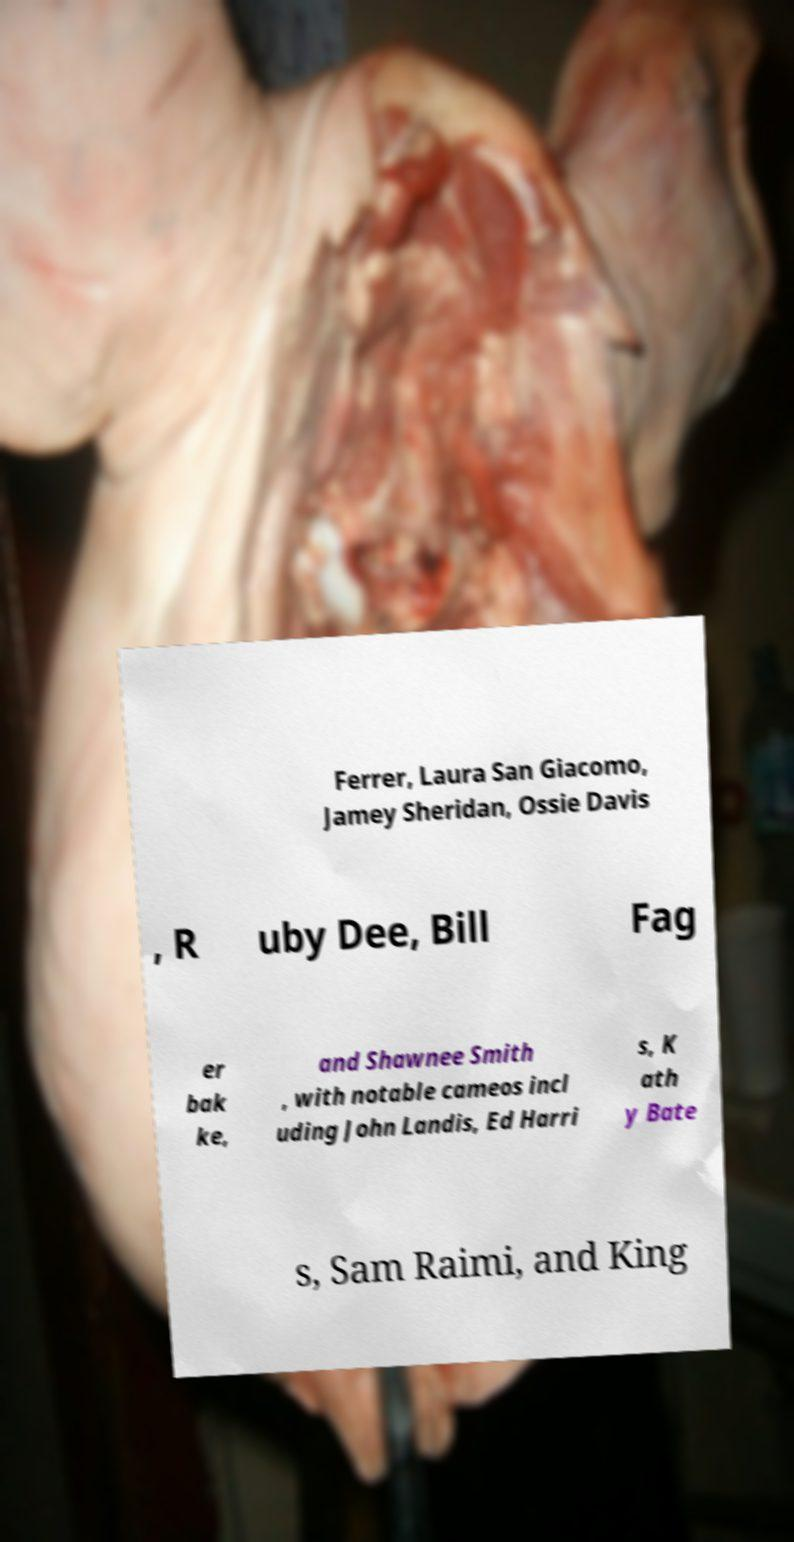Could you assist in decoding the text presented in this image and type it out clearly? Ferrer, Laura San Giacomo, Jamey Sheridan, Ossie Davis , R uby Dee, Bill Fag er bak ke, and Shawnee Smith , with notable cameos incl uding John Landis, Ed Harri s, K ath y Bate s, Sam Raimi, and King 